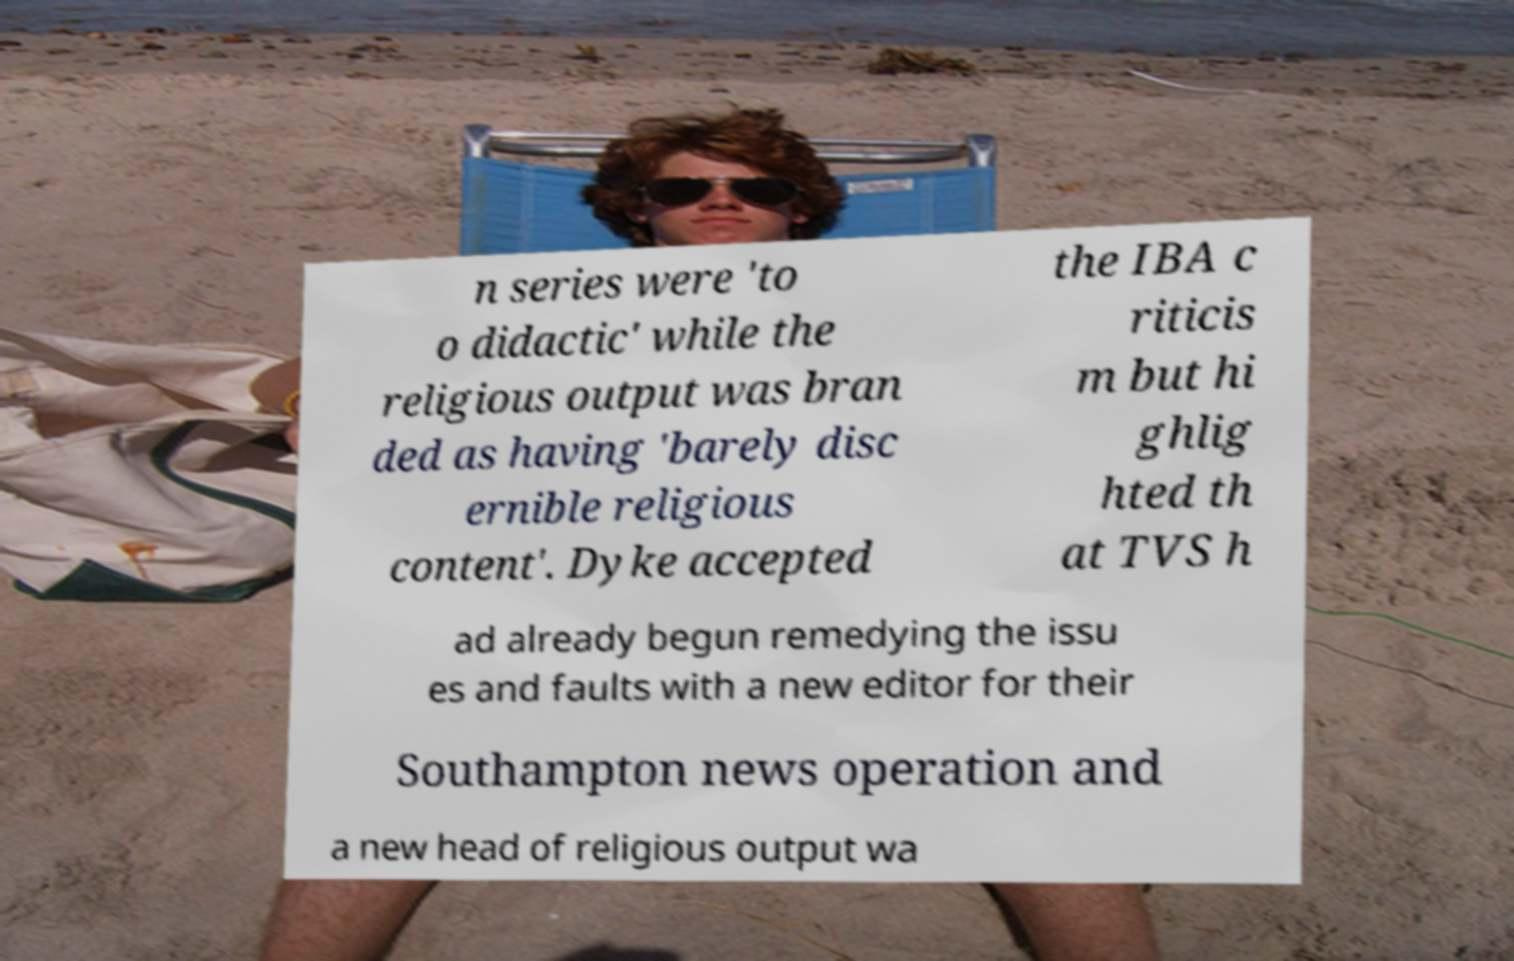Can you accurately transcribe the text from the provided image for me? n series were 'to o didactic' while the religious output was bran ded as having 'barely disc ernible religious content'. Dyke accepted the IBA c riticis m but hi ghlig hted th at TVS h ad already begun remedying the issu es and faults with a new editor for their Southampton news operation and a new head of religious output wa 